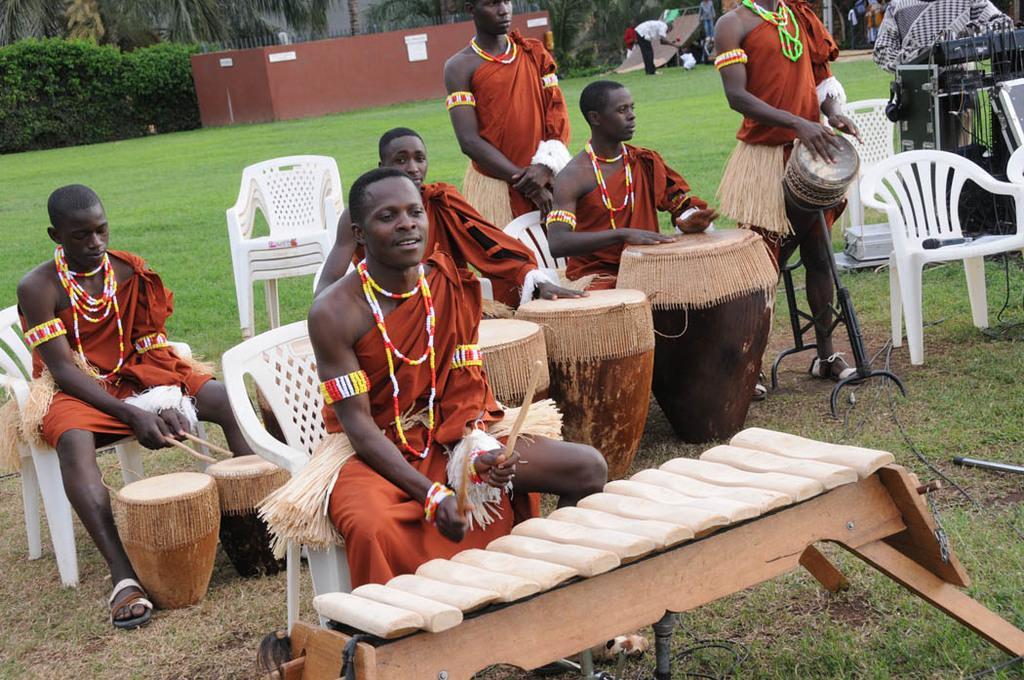Can you describe this image briefly? Here we see a group of people playing musical instruments by sitting on the chairs 